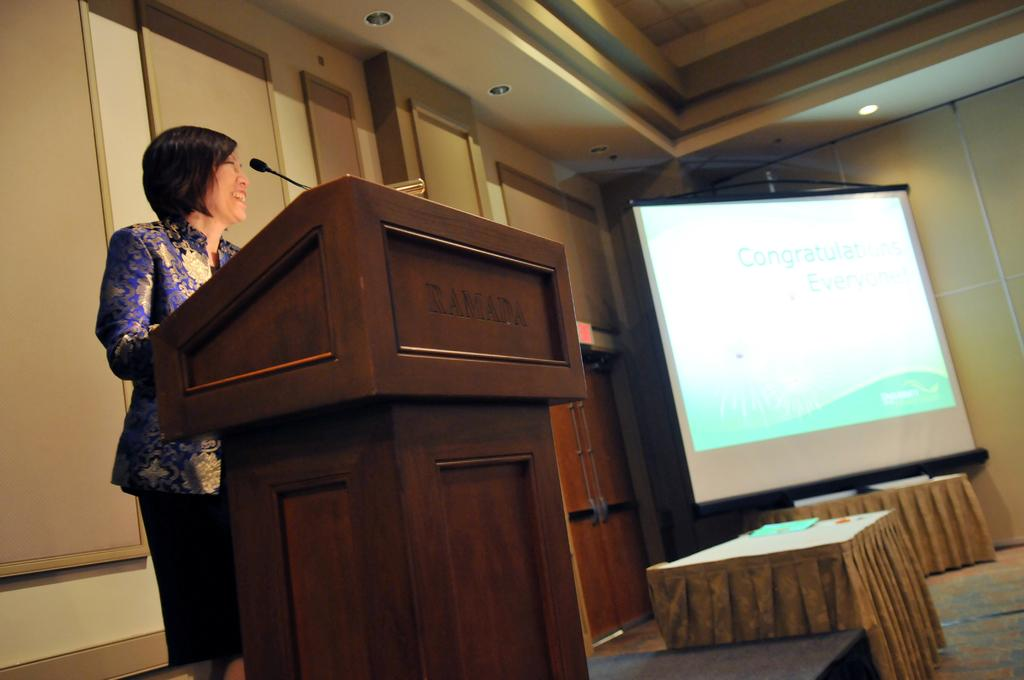What is the person near in the image? The person is standing near a podium in the image. What device is present for amplifying the person's voice? There is a microphone (mike) in the image. What type of furniture can be seen in the image? There are tables in the image. What is used for displaying information or visuals in the image? There is a screen in the image. What is providing illumination in the image? There are lights in the image. What decorative elements are attached to the wall in the background? There are frames attached to the wall in the background. What type of island is visible in the background of the image? There is no island visible in the background of the image. What is the person's dad doing in the image? The provided facts do not mention a dad or any other person in the image, so it is impossible to answer this question. 